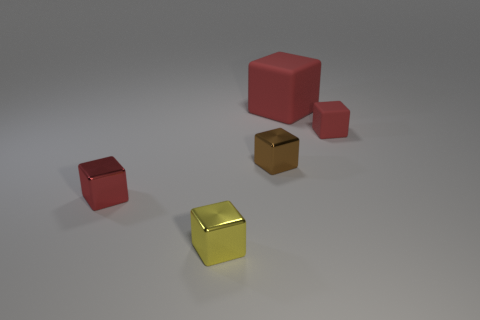What could be the purpose of arranging these objects this way? Is there a practical use or concept behind it? This composition seems to be a deliberate arrangement potentially designed for aesthetic or illustrative purposes. It may be an artistic visual representation to study color contrast, light reflection, and shadow casting. Alternatively, it could serve as a setting for educational content, like a tutorial or exercise in 3D modeling, teaching about object placement, and perspective. There's also a possibility it's a display of items in a color, size, or material study. Without additional context, the exact purpose is open to interpretation, but these are a few plausible concepts for the arrangement of these objects. 